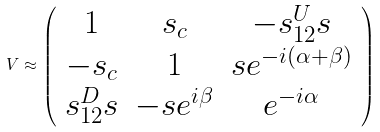<formula> <loc_0><loc_0><loc_500><loc_500>V \approx \left ( \begin{array} { c c c } 1 & s _ { c } & - s _ { 1 2 } ^ { U } s \\ - s _ { c } & 1 & s e ^ { - i ( \alpha + \beta ) } \\ s _ { 1 2 } ^ { D } s & - s e ^ { i \beta } & e ^ { - i \alpha } \end{array} \right )</formula> 